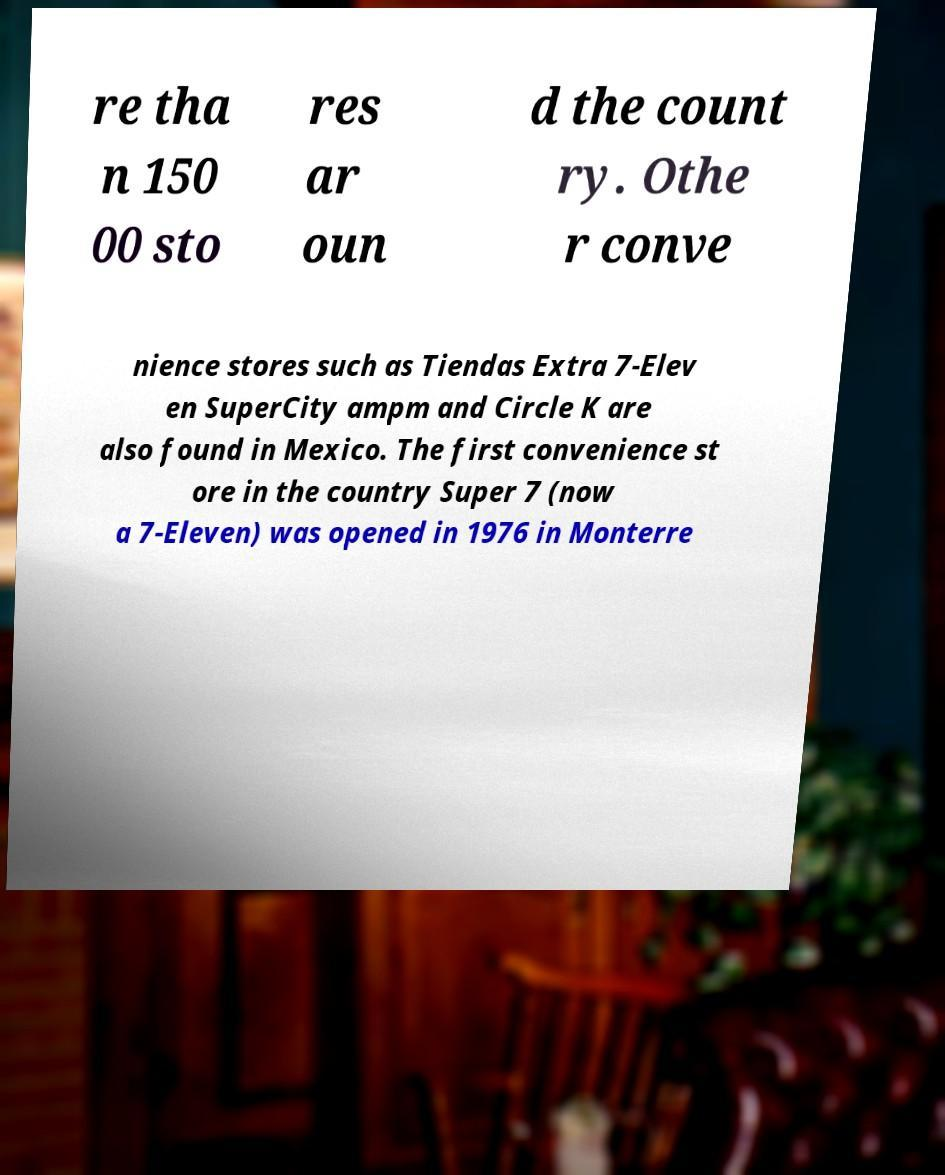Could you extract and type out the text from this image? re tha n 150 00 sto res ar oun d the count ry. Othe r conve nience stores such as Tiendas Extra 7-Elev en SuperCity ampm and Circle K are also found in Mexico. The first convenience st ore in the country Super 7 (now a 7-Eleven) was opened in 1976 in Monterre 